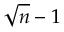<formula> <loc_0><loc_0><loc_500><loc_500>{ \sqrt { n } } - 1</formula> 